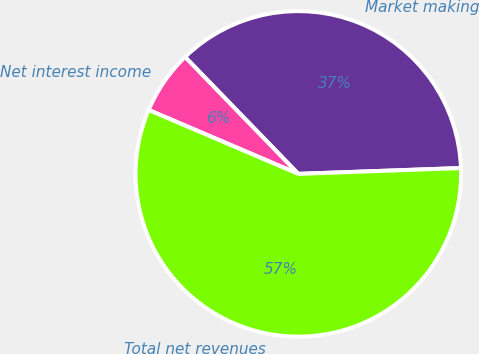Convert chart to OTSL. <chart><loc_0><loc_0><loc_500><loc_500><pie_chart><fcel>Market making<fcel>Net interest income<fcel>Total net revenues<nl><fcel>36.68%<fcel>6.33%<fcel>56.99%<nl></chart> 